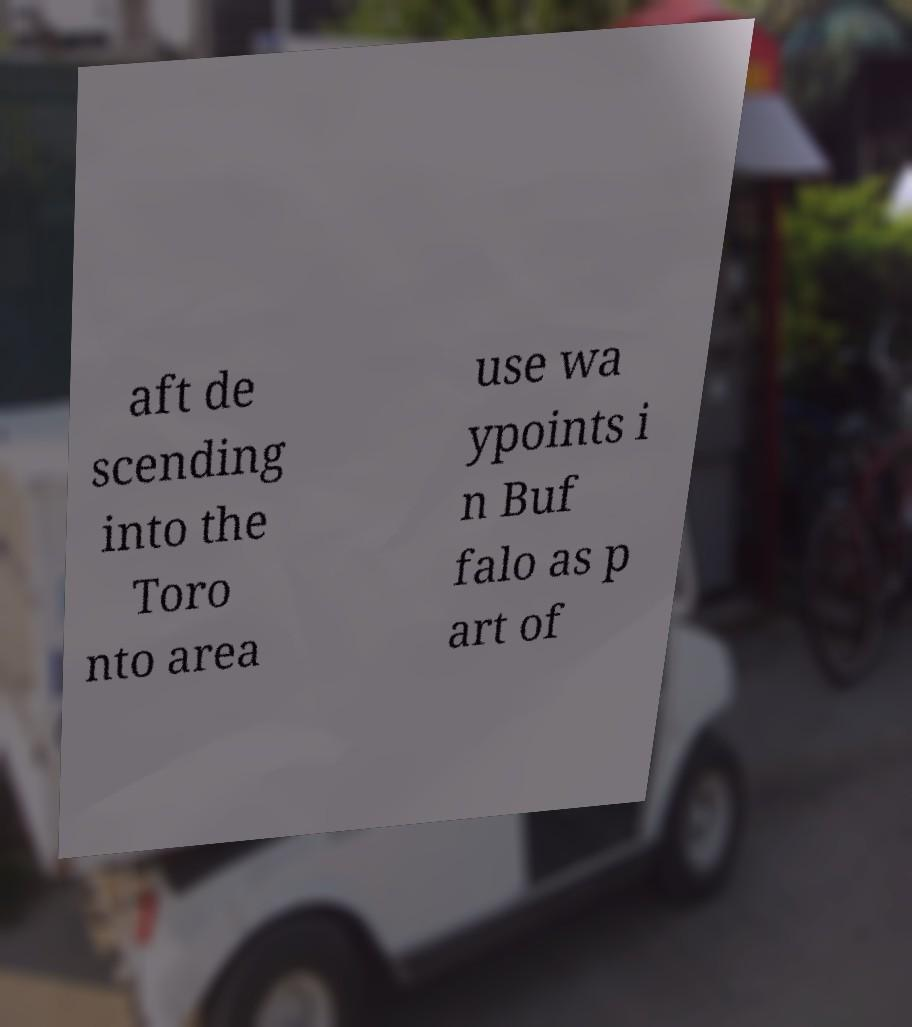Please read and relay the text visible in this image. What does it say? aft de scending into the Toro nto area use wa ypoints i n Buf falo as p art of 